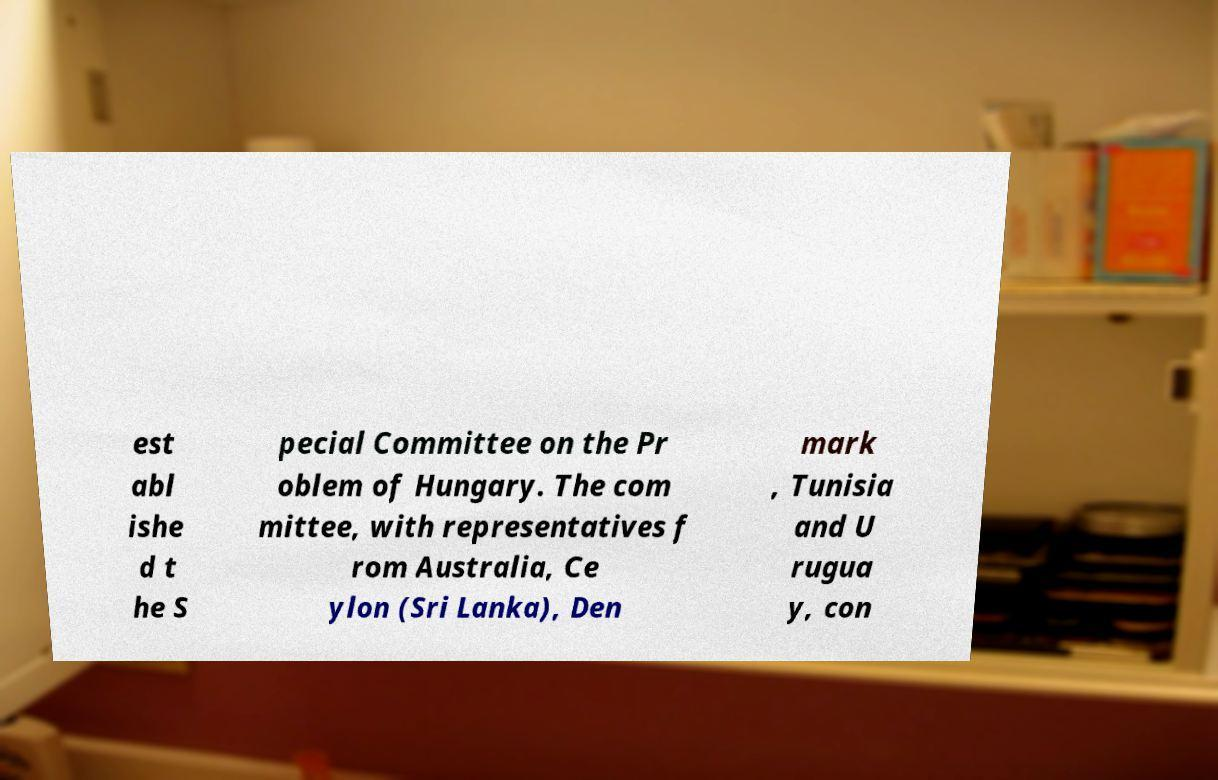Can you read and provide the text displayed in the image?This photo seems to have some interesting text. Can you extract and type it out for me? est abl ishe d t he S pecial Committee on the Pr oblem of Hungary. The com mittee, with representatives f rom Australia, Ce ylon (Sri Lanka), Den mark , Tunisia and U rugua y, con 